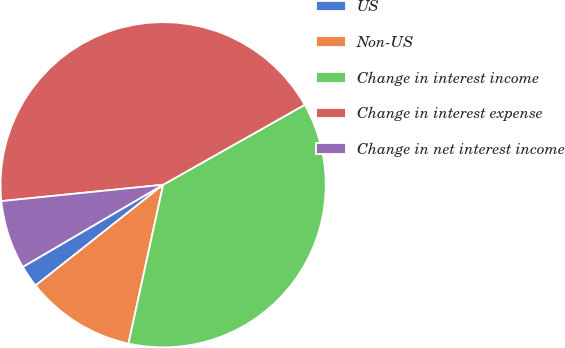Convert chart to OTSL. <chart><loc_0><loc_0><loc_500><loc_500><pie_chart><fcel>US<fcel>Non-US<fcel>Change in interest income<fcel>Change in interest expense<fcel>Change in net interest income<nl><fcel>2.21%<fcel>10.94%<fcel>36.6%<fcel>43.42%<fcel>6.82%<nl></chart> 